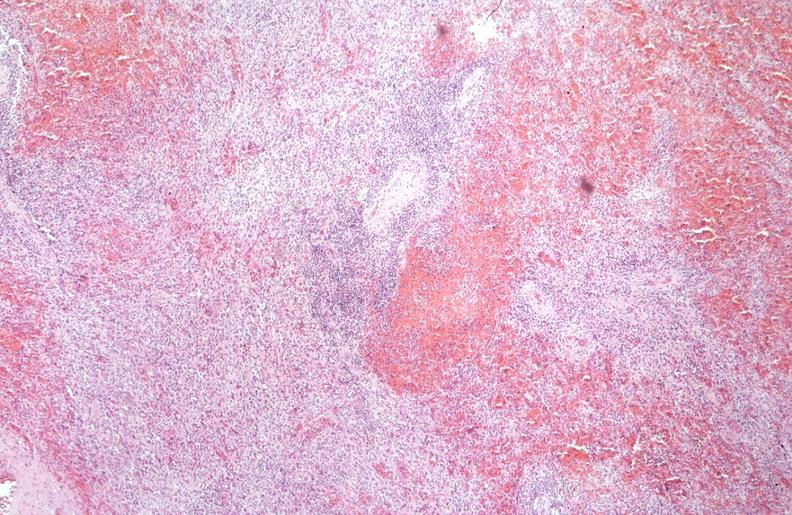does this image show spleen, chronic congestion due to portal hypertension from cirrhosis, hcv?
Answer the question using a single word or phrase. Yes 